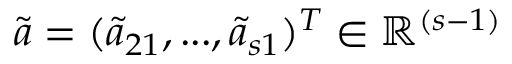<formula> <loc_0><loc_0><loc_500><loc_500>\tilde { a } = ( \tilde { a } _ { 2 1 } , \dots , \tilde { a } _ { s 1 } ) ^ { T } \in \mathbb { R } ^ { ( s - 1 ) }</formula> 